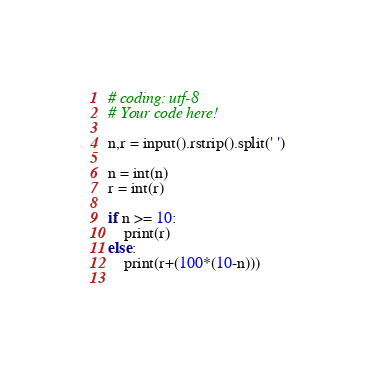<code> <loc_0><loc_0><loc_500><loc_500><_Python_># coding: utf-8
# Your code here!

n,r = input().rstrip().split(' ')

n = int(n)
r = int(r)

if n >= 10:
    print(r)
else:
    print(r+(100*(10-n)))
    </code> 